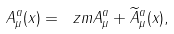<formula> <loc_0><loc_0><loc_500><loc_500>A ^ { a } _ { \mu } ( x ) = \ z m { A ^ { a } _ { \mu } } + \widetilde { A } ^ { a } _ { \mu } ( x ) ,</formula> 